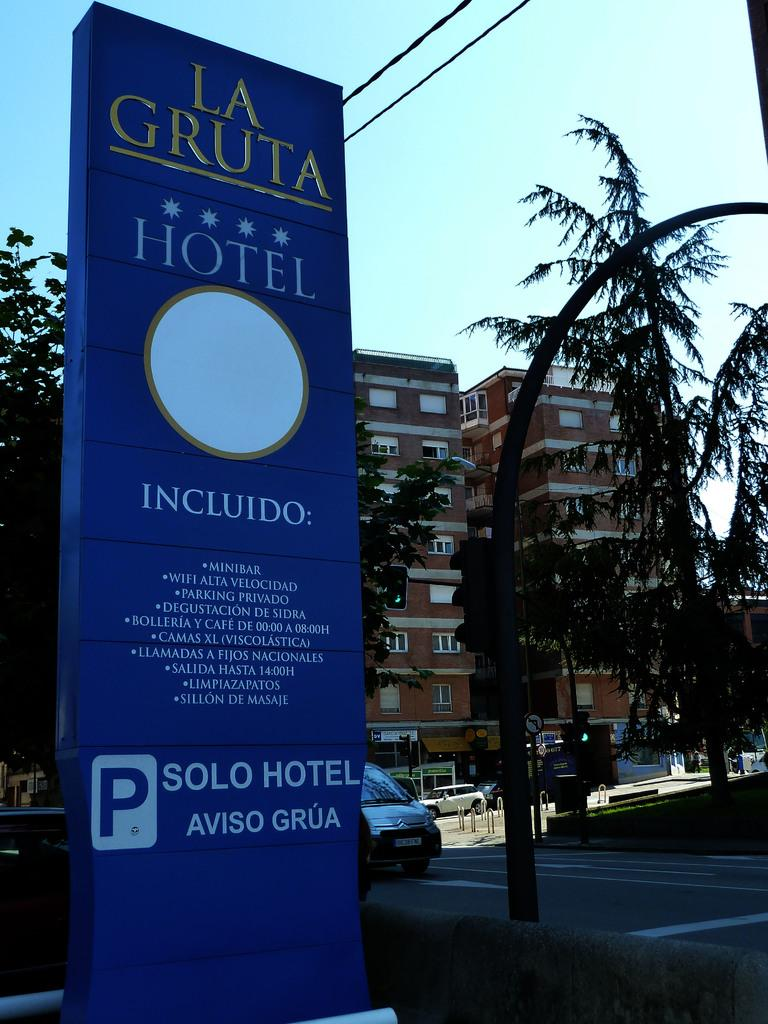What can be seen in the sky in the image? The sky is visible in the image. What type of structures are present in the image? There are buildings in the image. What other natural elements can be seen in the image? Trees are present in the image. What man-made objects are visible in the image? Vehicles are visible in the image. What type of signage is present in the image? There is a sign board in the image. What additional infrastructure elements are present in the image? Poles and wires are present in the image. What is the main focus of the image? The image is mainly highlighted by a hoarding. Can you see any cobwebs on the trees in the image? There is no mention of cobwebs in the image, so it cannot be determined if any are present. What type of waste is visible in the image? There is no mention of waste in the image, so it cannot be determined if any is present. 